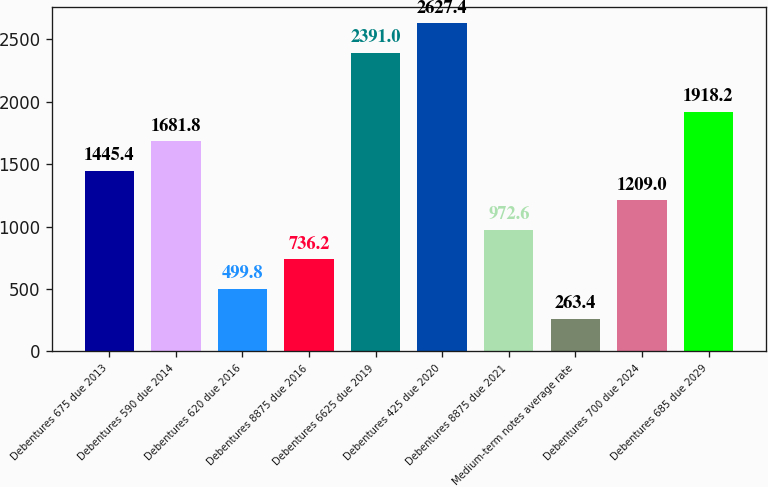Convert chart. <chart><loc_0><loc_0><loc_500><loc_500><bar_chart><fcel>Debentures 675 due 2013<fcel>Debentures 590 due 2014<fcel>Debentures 620 due 2016<fcel>Debentures 8875 due 2016<fcel>Debentures 6625 due 2019<fcel>Debentures 425 due 2020<fcel>Debentures 8875 due 2021<fcel>Medium-term notes average rate<fcel>Debentures 700 due 2024<fcel>Debentures 685 due 2029<nl><fcel>1445.4<fcel>1681.8<fcel>499.8<fcel>736.2<fcel>2391<fcel>2627.4<fcel>972.6<fcel>263.4<fcel>1209<fcel>1918.2<nl></chart> 